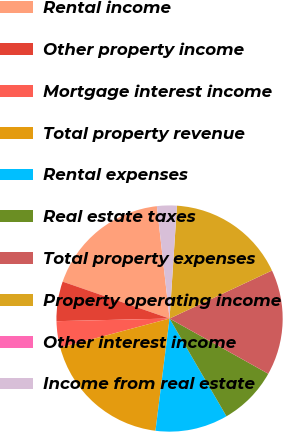Convert chart. <chart><loc_0><loc_0><loc_500><loc_500><pie_chart><fcel>Rental income<fcel>Other property income<fcel>Mortgage interest income<fcel>Total property revenue<fcel>Rental expenses<fcel>Real estate taxes<fcel>Total property expenses<fcel>Property operating income<fcel>Other interest income<fcel>Income from real estate<nl><fcel>17.92%<fcel>5.66%<fcel>3.78%<fcel>18.86%<fcel>10.38%<fcel>8.49%<fcel>15.09%<fcel>16.98%<fcel>0.0%<fcel>2.83%<nl></chart> 